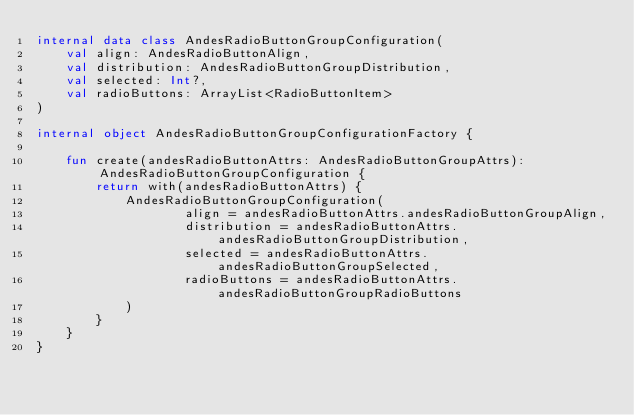Convert code to text. <code><loc_0><loc_0><loc_500><loc_500><_Kotlin_>internal data class AndesRadioButtonGroupConfiguration(
    val align: AndesRadioButtonAlign,
    val distribution: AndesRadioButtonGroupDistribution,
    val selected: Int?,
    val radioButtons: ArrayList<RadioButtonItem>
)

internal object AndesRadioButtonGroupConfigurationFactory {

    fun create(andesRadioButtonAttrs: AndesRadioButtonGroupAttrs): AndesRadioButtonGroupConfiguration {
        return with(andesRadioButtonAttrs) {
            AndesRadioButtonGroupConfiguration(
                    align = andesRadioButtonAttrs.andesRadioButtonGroupAlign,
                    distribution = andesRadioButtonAttrs.andesRadioButtonGroupDistribution,
                    selected = andesRadioButtonAttrs.andesRadioButtonGroupSelected,
                    radioButtons = andesRadioButtonAttrs.andesRadioButtonGroupRadioButtons
            )
        }
    }
}
</code> 